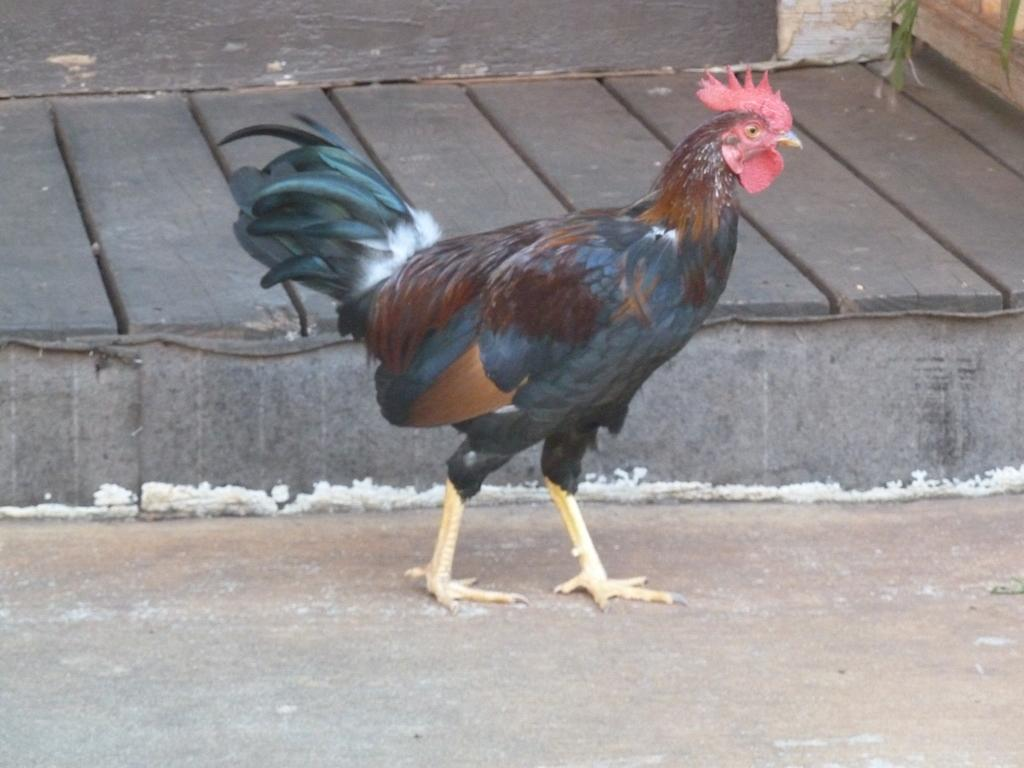What animal is in the front of the image? There is a rooster in the front of the image. What type of objects can be seen in the background of the image? There are flat stones in the background of the image. What part of a plant is visible at the top right corner of the image? Leaves of a plant are visible at the top right corner of the image. What type of pipe is the judge smoking in the image? There is no judge or pipe present in the image; it features a rooster, flat stones, and plant leaves. 